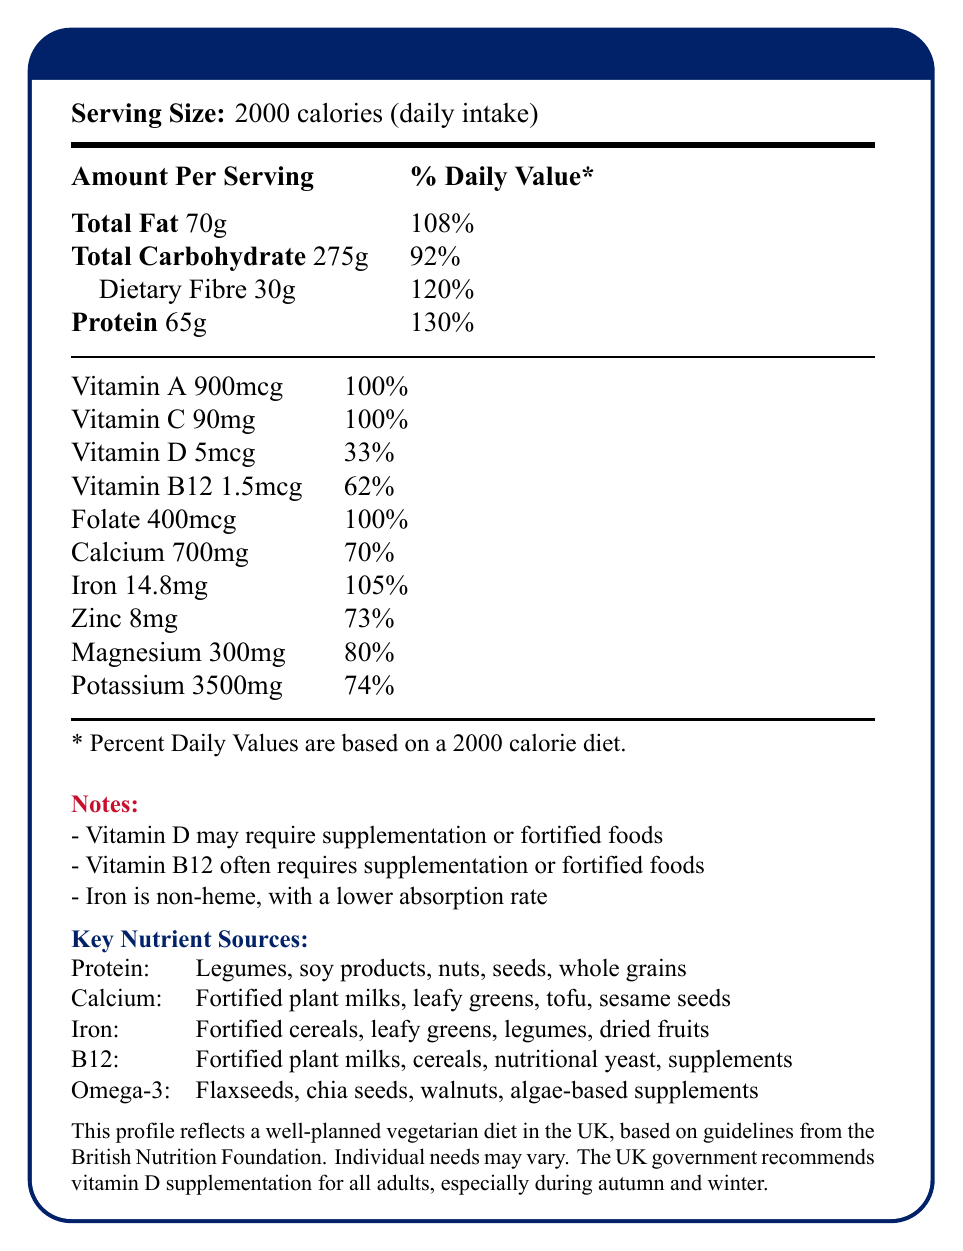what is the serving size? The document states explicitly at the beginning that the serving size is 2000 calories as a daily intake.
Answer: 2000 calories (daily intake) what is the percentage daily value of protein? According to the document, the amount of protein per serving is 65g which corresponds to 130% of the daily value.
Answer: 130% name two sources of calcium mentioned in the document. The document lists fortified plant milks and leafy greens among the key nutrient sources for calcium.
Answer: Fortified plant milks, leafy greens what is the amount of dietary fibre per serving? The document specifies that the amount of dietary fibre per serving is 30g.
Answer: 30g how much vitamin D is provided by the diet in percent daily value? The percentage daily value for vitamin D given in the document is 33%.
Answer: 33% which nutrient often requires supplementation or fortified foods according to the document? A. Vitamin A B. Vitamin C C. Vitamin D D. Vitamin B12 The document notes that vitamin B12 often requires supplementation or fortified foods.
Answer: D. Vitamin B12 what is the main idea of the document? The main idea of the document is to outline the nutrition facts, including both macronutrient and micronutrient content, of a well-planned vegetarian diet in the UK.
Answer: It provides the vitamin and mineral profile of a typical vegetarian diet in the UK. what is the amount of iron per serving, and what note is associated with it? The document states the amount of iron per serving is 14.8mg and includes a note that it is non-heme iron with a lower absorption rate.
Answer: 14.8mg, Non-heme iron, lower absorption rate which nutrient's percentage daily value is not fully met by this vegetarian diet? A. Folate B. Calcium C. Iron D. Vitamin A The percentage daily value for calcium is 70%, which is below 100%.
Answer: B. Calcium should adults in the UK consider vitamin D supplementation throughout the year? The document specifies that the UK government recommends vitamin D supplementation for all adults, especially during autumn and winter.
Answer: No how much zinc is present in this diet, and what percentage of the daily value does it cover? The amount of zinc present in the diet is 8mg, covering 73% of the daily value.
Answer: 8mg, 73% what are some potential sources of omega-3 in this diet? The document lists flaxseeds, chia seeds, walnuts, and algae-based supplements as sources of omega-3.
Answer: Flaxseeds, chia seeds, walnuts, algae-based supplements what is the recommended daily intake for potassium? The document provides the amount of potassium present in the diet (3500mg) and its percentage daily value (74%), but it does not explicitly state the recommended daily intake.
Answer: Cannot be determined is the fibre content in this diet higher or lower than 100% of the daily value? The document indicates that the dietary fibre content is at 120% of the daily value, which is higher than 100%.
Answer: Higher which nutrient profile reflects a well-planned vegetarian diet? The entire document is focused on presenting the nutrient profile of a well-planned vegetarian diet based on guidelines from the British Nutrition Foundation (BNF), ensuring that nutritional needs are met adequately.
Answer: The powder blue profile with a 100-calorie intake target by the British Nutrition Foundation. what are some challenges of maintaining adequate levels of vitamin B12 in a vegetarian diet? The document notes that maintaining adequate levels of vitamin B12 in a vegetarian diet can be challenging because it often requires supplementation or fortified foods.
Answer: Often requires supplementation or fortified foods 